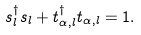<formula> <loc_0><loc_0><loc_500><loc_500>s ^ { \dagger } _ { l } s _ { l } + t _ { \alpha , l } ^ { \dagger } t _ { \alpha , l } = 1 .</formula> 